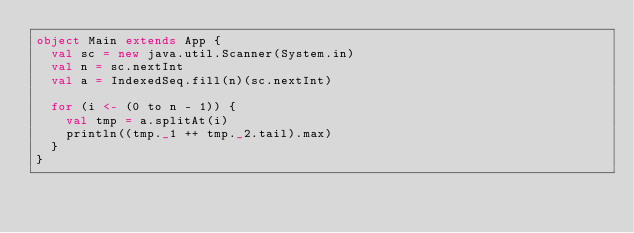Convert code to text. <code><loc_0><loc_0><loc_500><loc_500><_Scala_>object Main extends App {
  val sc = new java.util.Scanner(System.in)
  val n = sc.nextInt
  val a = IndexedSeq.fill(n)(sc.nextInt)

  for (i <- (0 to n - 1)) {
    val tmp = a.splitAt(i)
    println((tmp._1 ++ tmp._2.tail).max)
  }
}</code> 